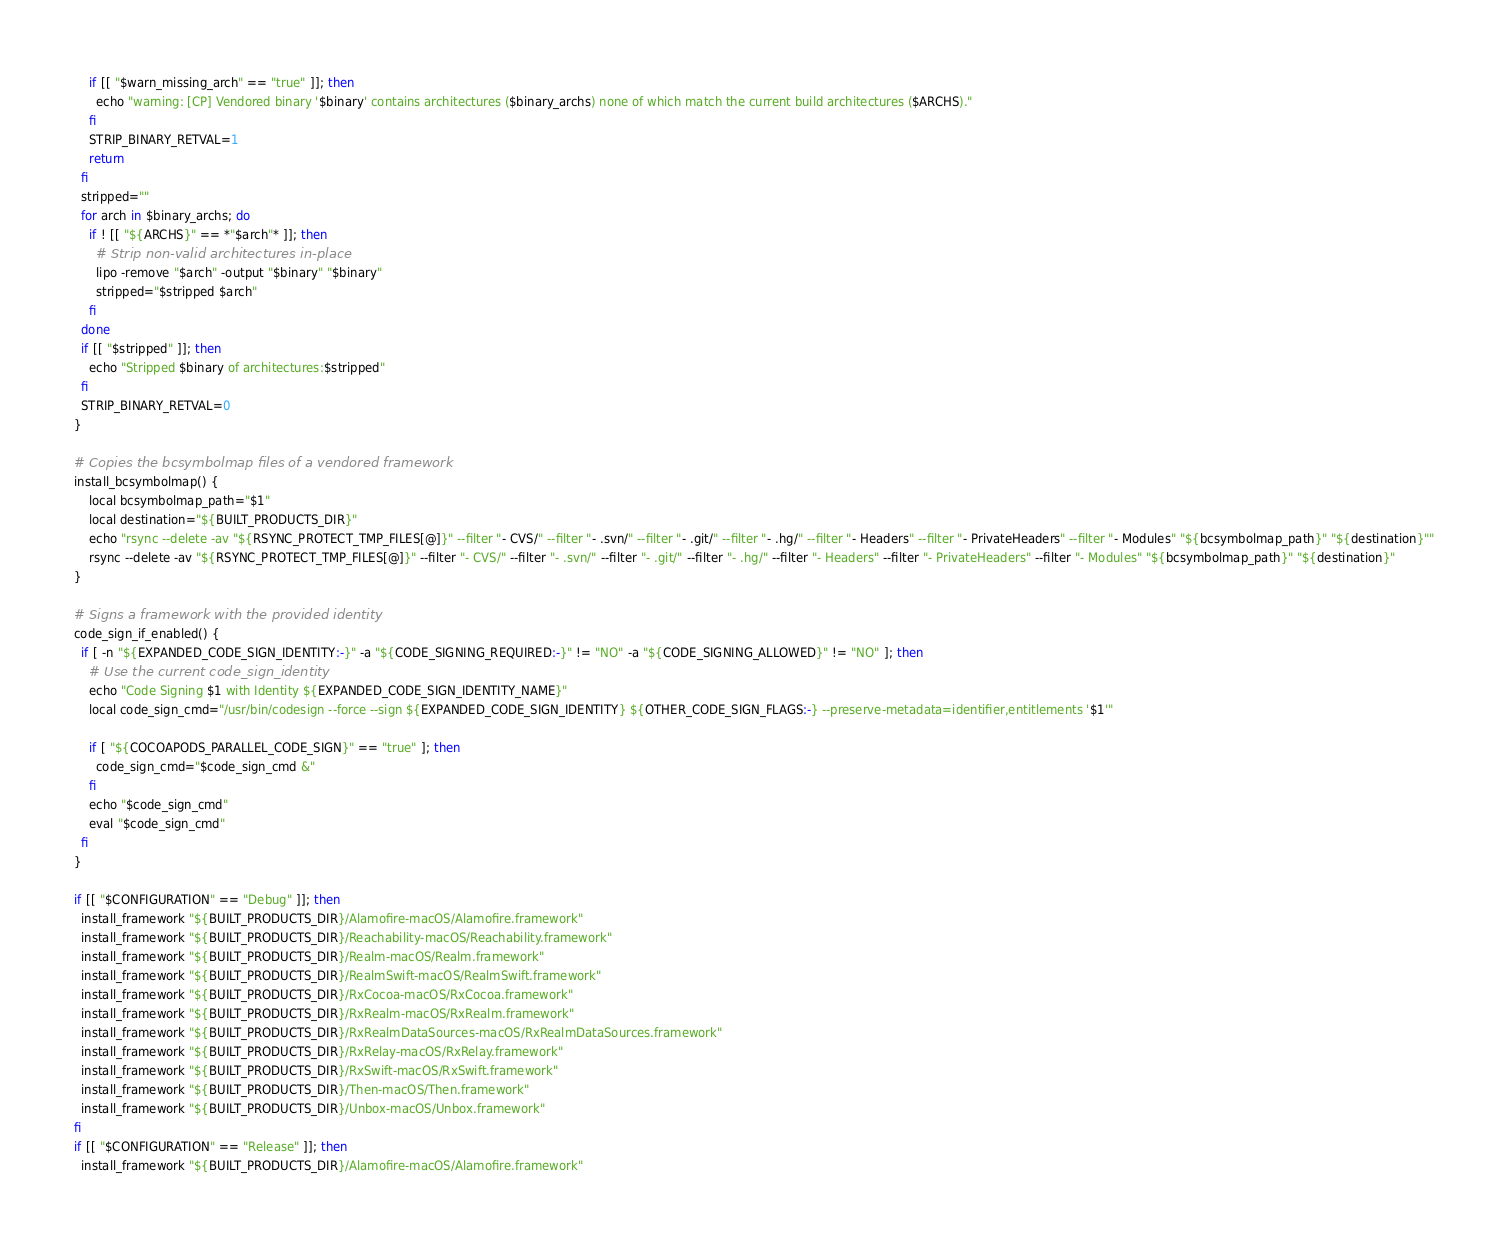<code> <loc_0><loc_0><loc_500><loc_500><_Bash_>    if [[ "$warn_missing_arch" == "true" ]]; then
      echo "warning: [CP] Vendored binary '$binary' contains architectures ($binary_archs) none of which match the current build architectures ($ARCHS)."
    fi
    STRIP_BINARY_RETVAL=1
    return
  fi
  stripped=""
  for arch in $binary_archs; do
    if ! [[ "${ARCHS}" == *"$arch"* ]]; then
      # Strip non-valid architectures in-place
      lipo -remove "$arch" -output "$binary" "$binary"
      stripped="$stripped $arch"
    fi
  done
  if [[ "$stripped" ]]; then
    echo "Stripped $binary of architectures:$stripped"
  fi
  STRIP_BINARY_RETVAL=0
}

# Copies the bcsymbolmap files of a vendored framework
install_bcsymbolmap() {
    local bcsymbolmap_path="$1"
    local destination="${BUILT_PRODUCTS_DIR}"
    echo "rsync --delete -av "${RSYNC_PROTECT_TMP_FILES[@]}" --filter "- CVS/" --filter "- .svn/" --filter "- .git/" --filter "- .hg/" --filter "- Headers" --filter "- PrivateHeaders" --filter "- Modules" "${bcsymbolmap_path}" "${destination}""
    rsync --delete -av "${RSYNC_PROTECT_TMP_FILES[@]}" --filter "- CVS/" --filter "- .svn/" --filter "- .git/" --filter "- .hg/" --filter "- Headers" --filter "- PrivateHeaders" --filter "- Modules" "${bcsymbolmap_path}" "${destination}"
}

# Signs a framework with the provided identity
code_sign_if_enabled() {
  if [ -n "${EXPANDED_CODE_SIGN_IDENTITY:-}" -a "${CODE_SIGNING_REQUIRED:-}" != "NO" -a "${CODE_SIGNING_ALLOWED}" != "NO" ]; then
    # Use the current code_sign_identity
    echo "Code Signing $1 with Identity ${EXPANDED_CODE_SIGN_IDENTITY_NAME}"
    local code_sign_cmd="/usr/bin/codesign --force --sign ${EXPANDED_CODE_SIGN_IDENTITY} ${OTHER_CODE_SIGN_FLAGS:-} --preserve-metadata=identifier,entitlements '$1'"

    if [ "${COCOAPODS_PARALLEL_CODE_SIGN}" == "true" ]; then
      code_sign_cmd="$code_sign_cmd &"
    fi
    echo "$code_sign_cmd"
    eval "$code_sign_cmd"
  fi
}

if [[ "$CONFIGURATION" == "Debug" ]]; then
  install_framework "${BUILT_PRODUCTS_DIR}/Alamofire-macOS/Alamofire.framework"
  install_framework "${BUILT_PRODUCTS_DIR}/Reachability-macOS/Reachability.framework"
  install_framework "${BUILT_PRODUCTS_DIR}/Realm-macOS/Realm.framework"
  install_framework "${BUILT_PRODUCTS_DIR}/RealmSwift-macOS/RealmSwift.framework"
  install_framework "${BUILT_PRODUCTS_DIR}/RxCocoa-macOS/RxCocoa.framework"
  install_framework "${BUILT_PRODUCTS_DIR}/RxRealm-macOS/RxRealm.framework"
  install_framework "${BUILT_PRODUCTS_DIR}/RxRealmDataSources-macOS/RxRealmDataSources.framework"
  install_framework "${BUILT_PRODUCTS_DIR}/RxRelay-macOS/RxRelay.framework"
  install_framework "${BUILT_PRODUCTS_DIR}/RxSwift-macOS/RxSwift.framework"
  install_framework "${BUILT_PRODUCTS_DIR}/Then-macOS/Then.framework"
  install_framework "${BUILT_PRODUCTS_DIR}/Unbox-macOS/Unbox.framework"
fi
if [[ "$CONFIGURATION" == "Release" ]]; then
  install_framework "${BUILT_PRODUCTS_DIR}/Alamofire-macOS/Alamofire.framework"</code> 